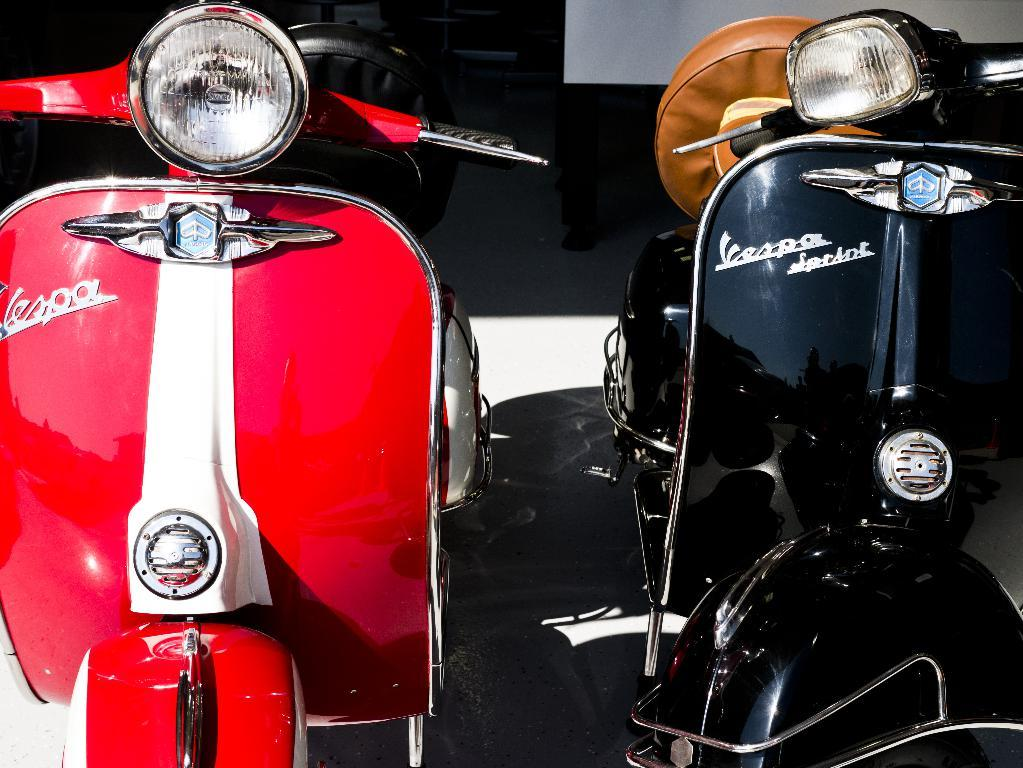What can be seen in the image? There are two bikes in the image. What is the condition of the bikes in the image? The bikes are parked. Where is the kettle located in the image? There is no kettle present in the image. What type of pets can be seen playing with the bikes in the image? There are no pets present in the image. How many potatoes are visible in the image? There are no potatoes present in the image. 